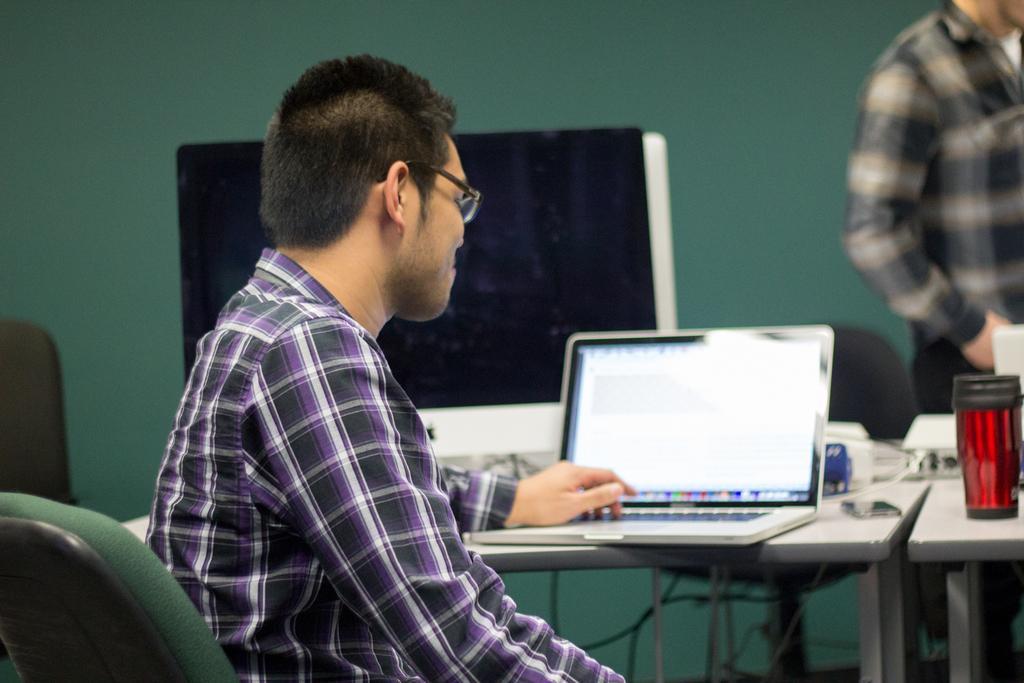How would you summarize this image in a sentence or two? In the image we can see there is a person who is sitting on chair and on table there is laptop and coffee glass and on the wall there is a projector screen and there is a person who is standing over here. 